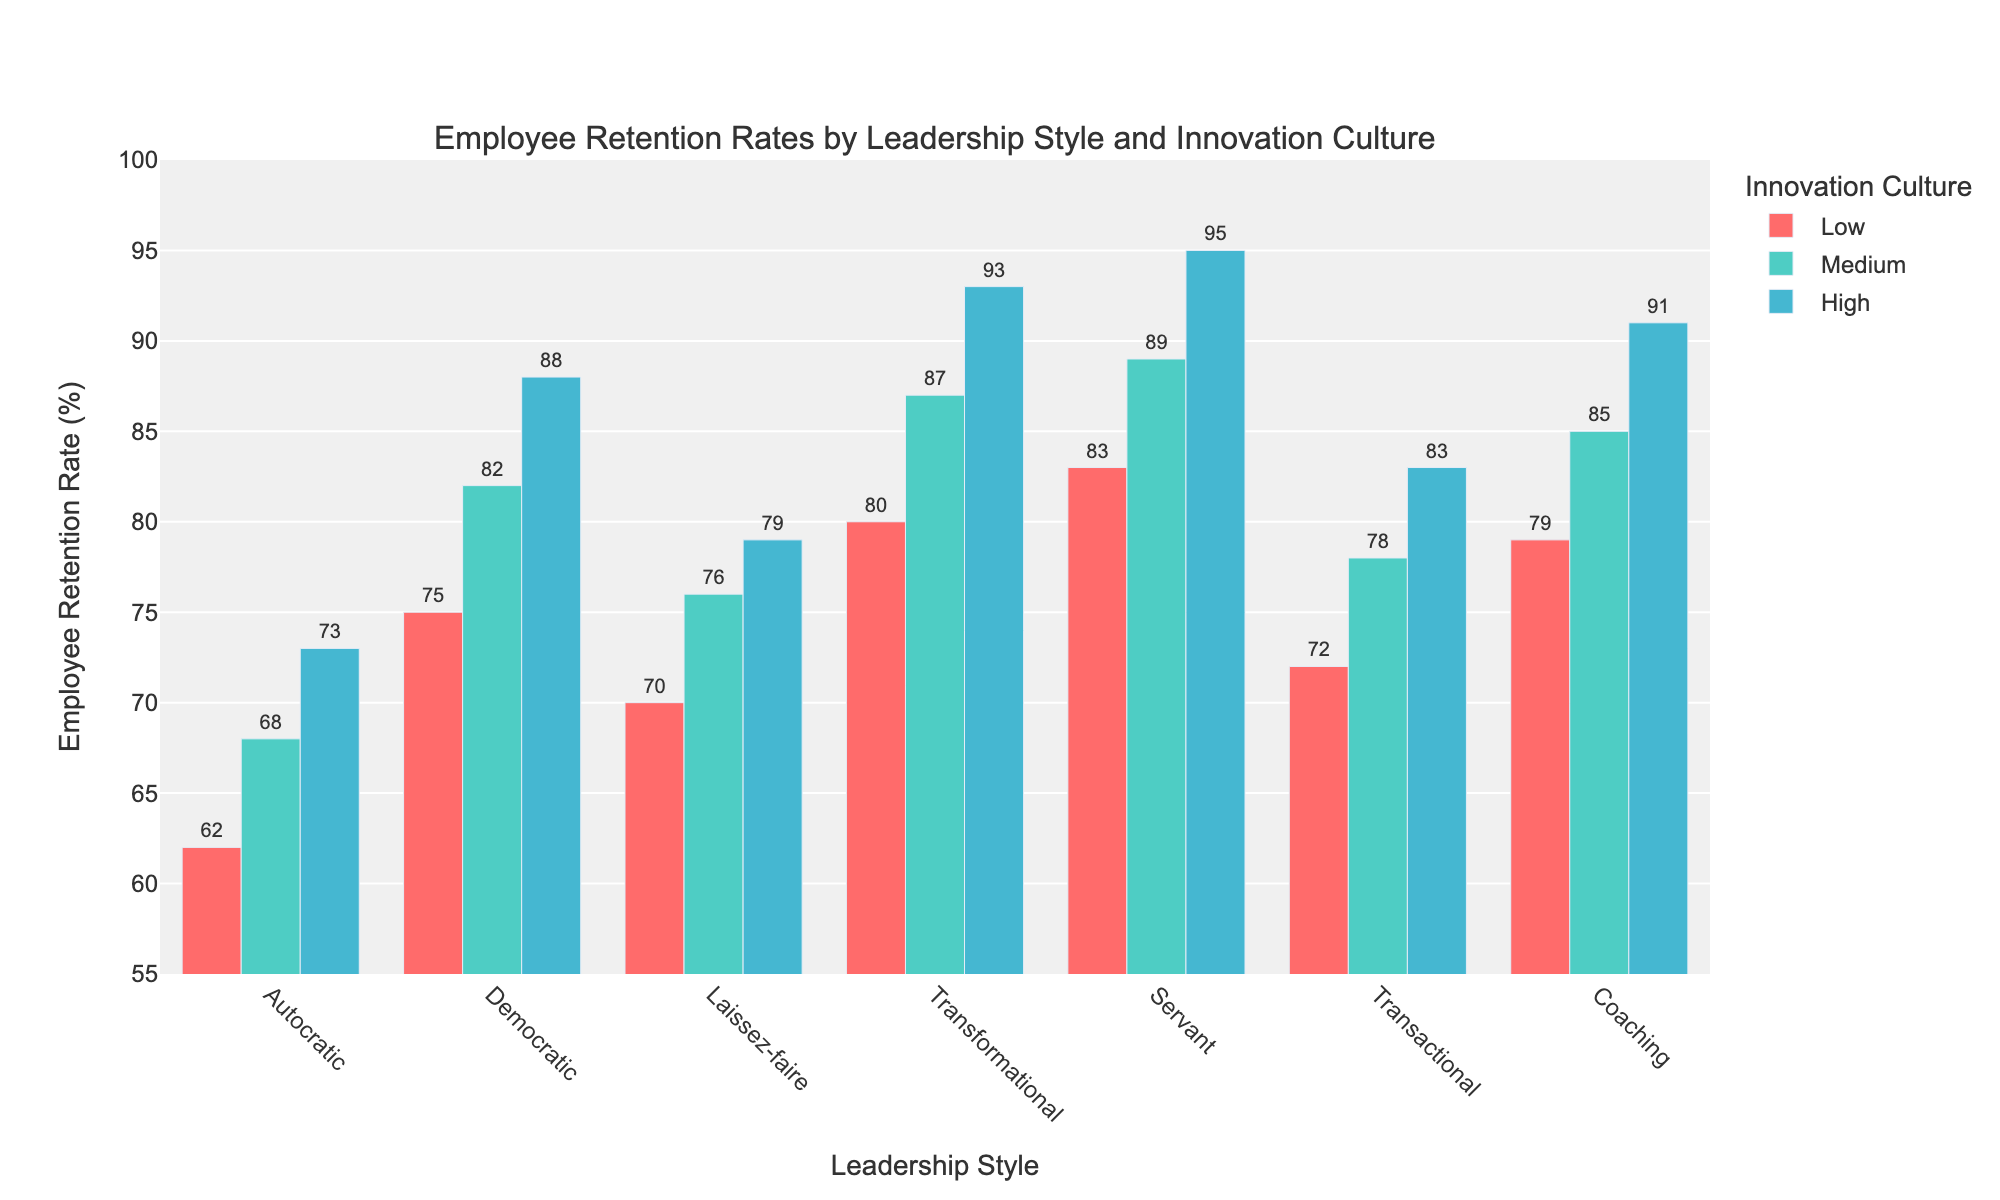What's the difference in employee retention rates between the highest innovation culture and the lowest innovation culture for Democratic leadership? For Democratic leadership, the retention rates for Low, Medium, and High innovation cultures are 75%, 82%, and 88% respectively. The difference between the highest (88%) and the lowest (75%) is 88 - 75.
Answer: 13 Which leadership style shows the highest employee retention rate for a medium level of innovation culture? For a medium level of innovation culture, the retention rates are as follows: Autocratic (68%), Democratic (82%), Laissez-faire (76%), Transformational (87%), Servant (89%), Transactional (78%), and Coaching (85%). The highest rate is 89%, which corresponds to the Servant leadership style.
Answer: Servant How does the employee retention rate for Laissez-faire leadership with a high innovation culture compare to that of Coaching leadership with a low innovation culture? For Laissez-faire leadership with a high innovation culture, the retention rate is 79%. For Coaching leadership with a low innovation culture, the retention rate is 79%. Both rates are equal.
Answer: Equal What is the average employee retention rate for all leadership styles at a high level of innovation culture? Adding the retention rates for high innovation culture across all leadership styles: 73 (Autocratic) + 88 (Democratic) + 79 (Laissez-faire) + 93 (Transformational) + 95 (Servant) + 83 (Transactional) + 91 (Coaching) = 602. Divide this sum by the number of leadership styles, which is 7. So, 602 / 7.
Answer: 86 Which leadership style has the lowest employee retention rate for a low level of innovation culture, and what is that rate? For a low level of innovation culture, the employee retention rates are: Autocratic (62%), Democratic (75%), Laissez-faire (70%), Transformational (80%), Servant (83%), Transactional (72%), and Coaching (79%). The lowest rate is 62%, which corresponds to the Autocratic leadership style.
Answer: Autocratic (62%) In terms of retention rates, which leadership style benefits the most from moving from a low to medium innovation culture? Calculate the difference between the retention rates for low and medium innovation cultures for each leadership style: 
- Autocratic: 68 - 62 = 6 
- Democratic: 82 - 75 = 7 
- Laissez-faire: 76 - 70 = 6 
- Transformational: 87 - 80 = 7 
- Servant: 89 - 83 = 6 
- Transactional: 78 - 72 = 6 
- Coaching: 85 - 79 = 6 
Both Democratic and Transformational leadership styles have the highest increase, which is 7%.
Answer: Democratic and Transformational What is the total employee retention rate sum across all innovation cultures for Transformational leadership? For Transformational leadership, the retention rates are 80% (Low), 87% (Medium), and 93% (High). The sum is 80 + 87 + 93.
Answer: 260 Between Servant and Transactional leadership, which has a higher retention rate for a high level of innovation culture, and by how much? For a high level of innovation culture, Servant's retention rate is 95% and Transactional's is 83%. The difference is 95 - 83.
Answer: Servant by 12 